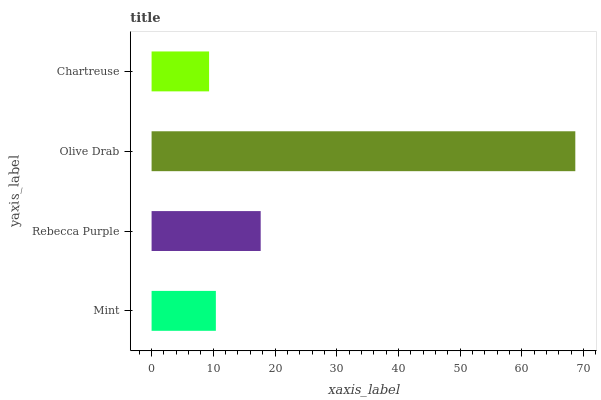Is Chartreuse the minimum?
Answer yes or no. Yes. Is Olive Drab the maximum?
Answer yes or no. Yes. Is Rebecca Purple the minimum?
Answer yes or no. No. Is Rebecca Purple the maximum?
Answer yes or no. No. Is Rebecca Purple greater than Mint?
Answer yes or no. Yes. Is Mint less than Rebecca Purple?
Answer yes or no. Yes. Is Mint greater than Rebecca Purple?
Answer yes or no. No. Is Rebecca Purple less than Mint?
Answer yes or no. No. Is Rebecca Purple the high median?
Answer yes or no. Yes. Is Mint the low median?
Answer yes or no. Yes. Is Chartreuse the high median?
Answer yes or no. No. Is Chartreuse the low median?
Answer yes or no. No. 